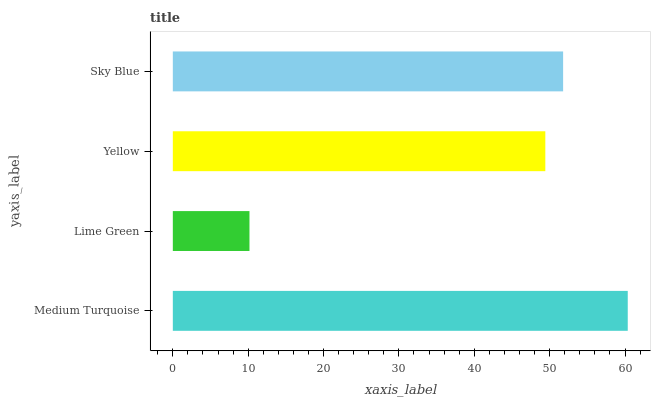Is Lime Green the minimum?
Answer yes or no. Yes. Is Medium Turquoise the maximum?
Answer yes or no. Yes. Is Yellow the minimum?
Answer yes or no. No. Is Yellow the maximum?
Answer yes or no. No. Is Yellow greater than Lime Green?
Answer yes or no. Yes. Is Lime Green less than Yellow?
Answer yes or no. Yes. Is Lime Green greater than Yellow?
Answer yes or no. No. Is Yellow less than Lime Green?
Answer yes or no. No. Is Sky Blue the high median?
Answer yes or no. Yes. Is Yellow the low median?
Answer yes or no. Yes. Is Medium Turquoise the high median?
Answer yes or no. No. Is Sky Blue the low median?
Answer yes or no. No. 